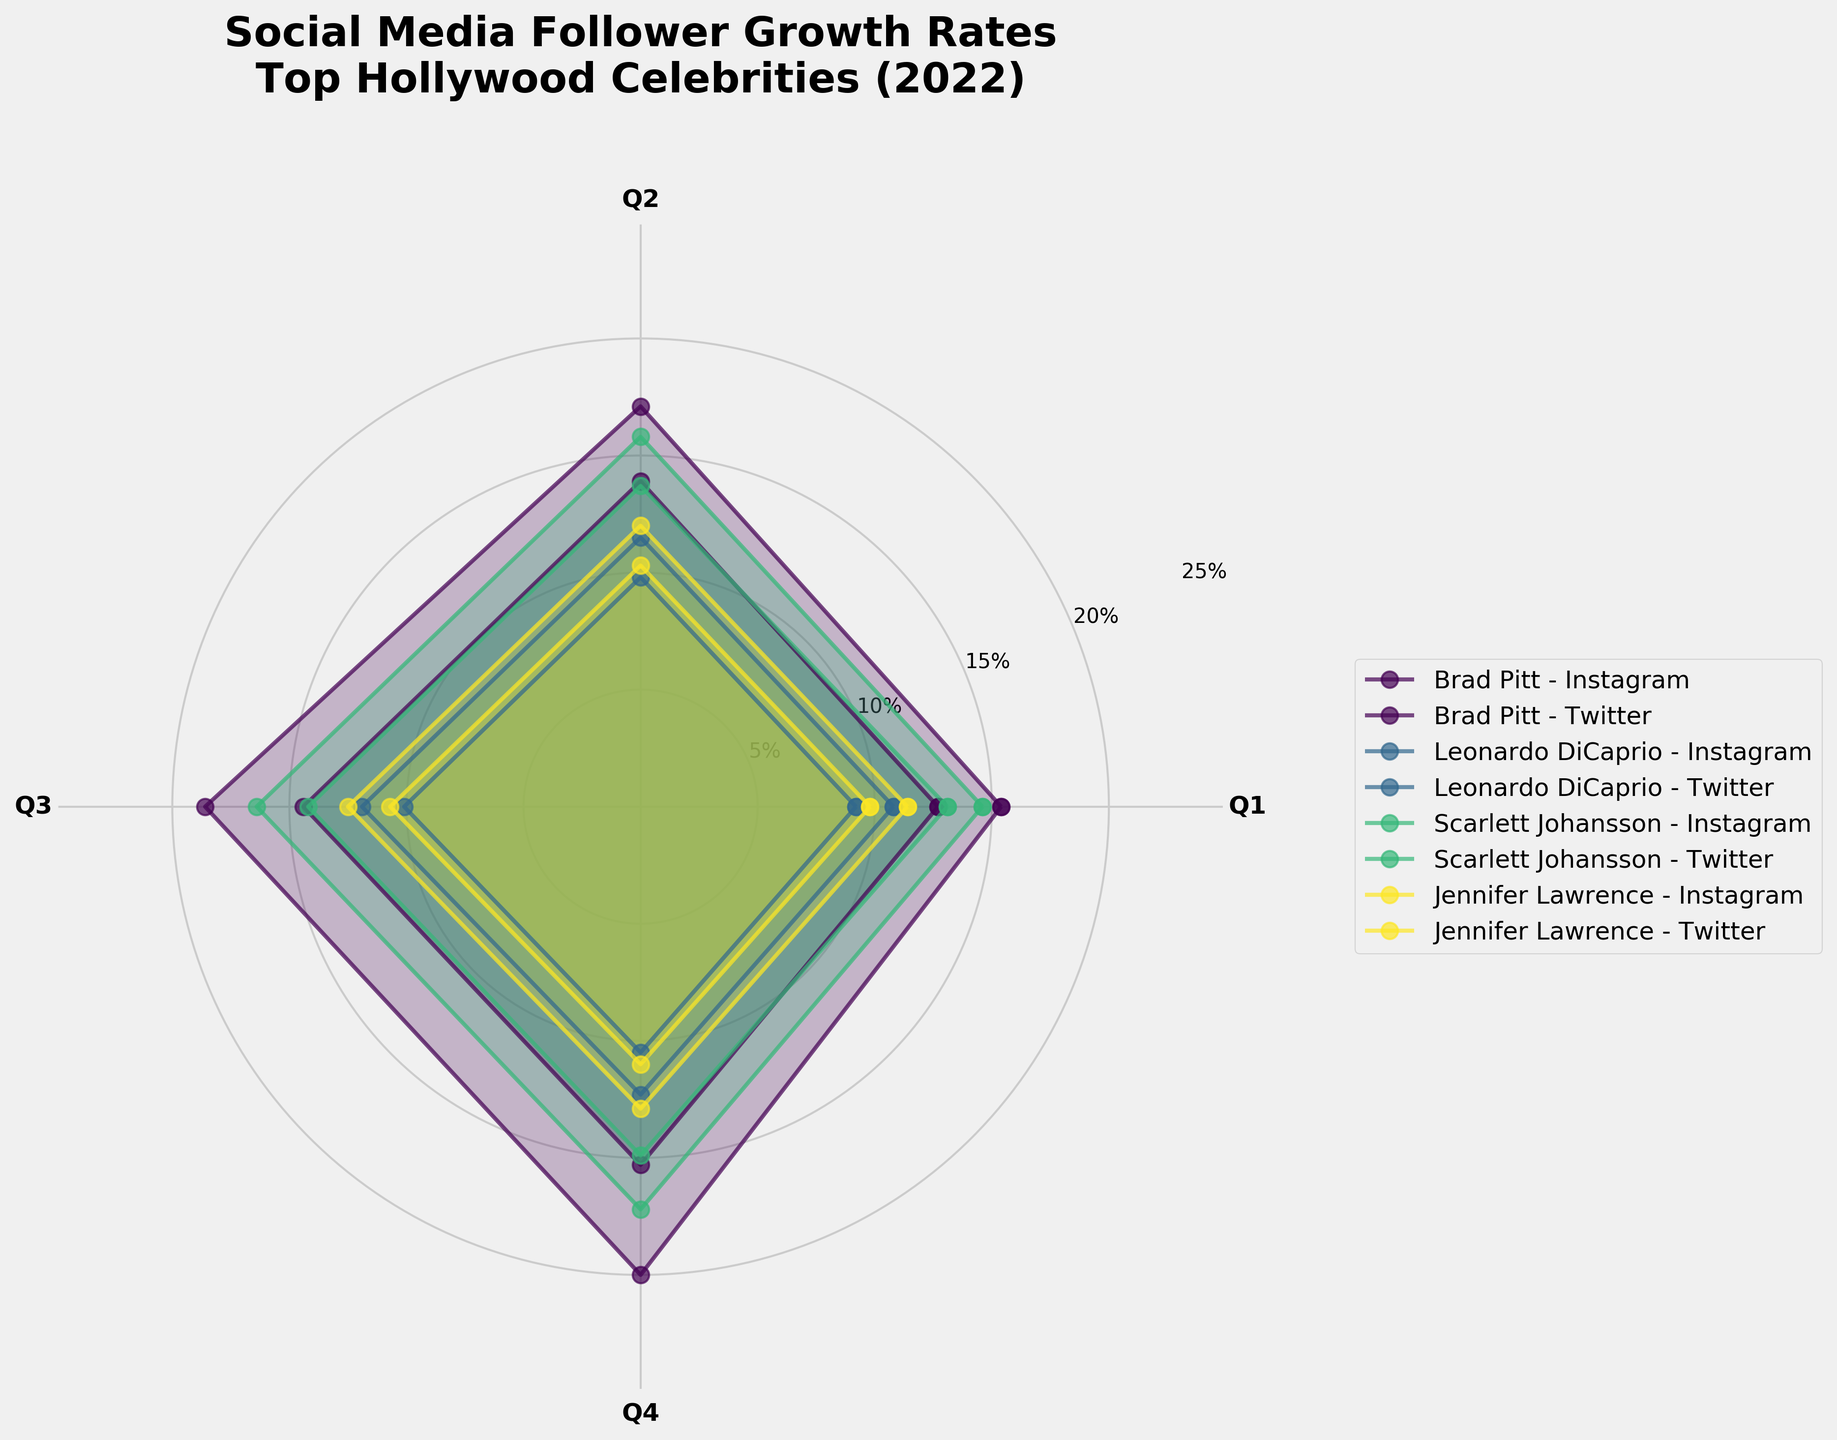What's the title of the figure? The title of the figure is prominently displayed at the top. It provides a clear summary of the figure's subject matter.
Answer: Social Media Follower Growth Rates Top Hollywood Celebrities (2022) Which celebrity has the highest follower growth rate on Instagram in Q4 2022? Identify the segment corresponding to Q4 on the radial plot and look at the length of the colored sections for Instagram. Compare their lengths to determine which is the longest.
Answer: Brad Pitt What is the range of the y-axis in the figure? Look at the axis labeled with percentages to find the minimum and maximum values it covers. This range indicates the possible follower growth rates.
Answer: 0% to 25% How many quarters are displayed for each celebrity? Count the number of distinct segments for a single celebrity-platform pair. Each segment corresponds to a quarter.
Answer: 4 What is the average follower growth rate for Jennifer Lawrence on Twitter in 2022? Sum the four follower growth rates for Jennifer Lawrence on Twitter, then divide by the number of quarters (4). The values are 9.8, 10.3, 10.7, and 11.0.
Answer: 10.45% Which platform had a generally higher growth rate for Scarlett Johansson, Instagram or Twitter? Compare the height of Scarlett Johansson's segments for both Instagram and Twitter across all quarters. Check which segments are generally longer.
Answer: Instagram Does Brad Pitt's follower growth rate on Twitter show a consistent increase over the year? Follow the segments for Brad Pitt on Twitter from Q1 to Q4. Compare each segment's height to the previous one to see if each is consistently higher than the last.
Answer: Yes Who had the lowest follower growth rate on Instagram in Q1 2022? Identify the Q1 segments on Instagram. Compare their lengths to find the shortest one.
Answer: Leonardo DiCaprio Compare the follower growth rates of Brad Pitt and Leonardo DiCaprio on Instagram in Q2. Who had a higher rate? Find the Q2 segments for both Brad Pitt and Leonardo DiCaprio on Instagram. Measure which segment is longer.
Answer: Brad Pitt Which quarter shows the highest follower growth rate for Scarlett Johansson on Twitter? Look at Scarlett Johansson’s Twitter segments and identify the one that extends the most from the center.
Answer: Q4 